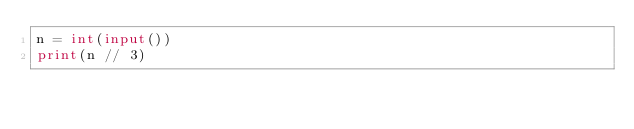<code> <loc_0><loc_0><loc_500><loc_500><_Python_>n = int(input())
print(n // 3)</code> 